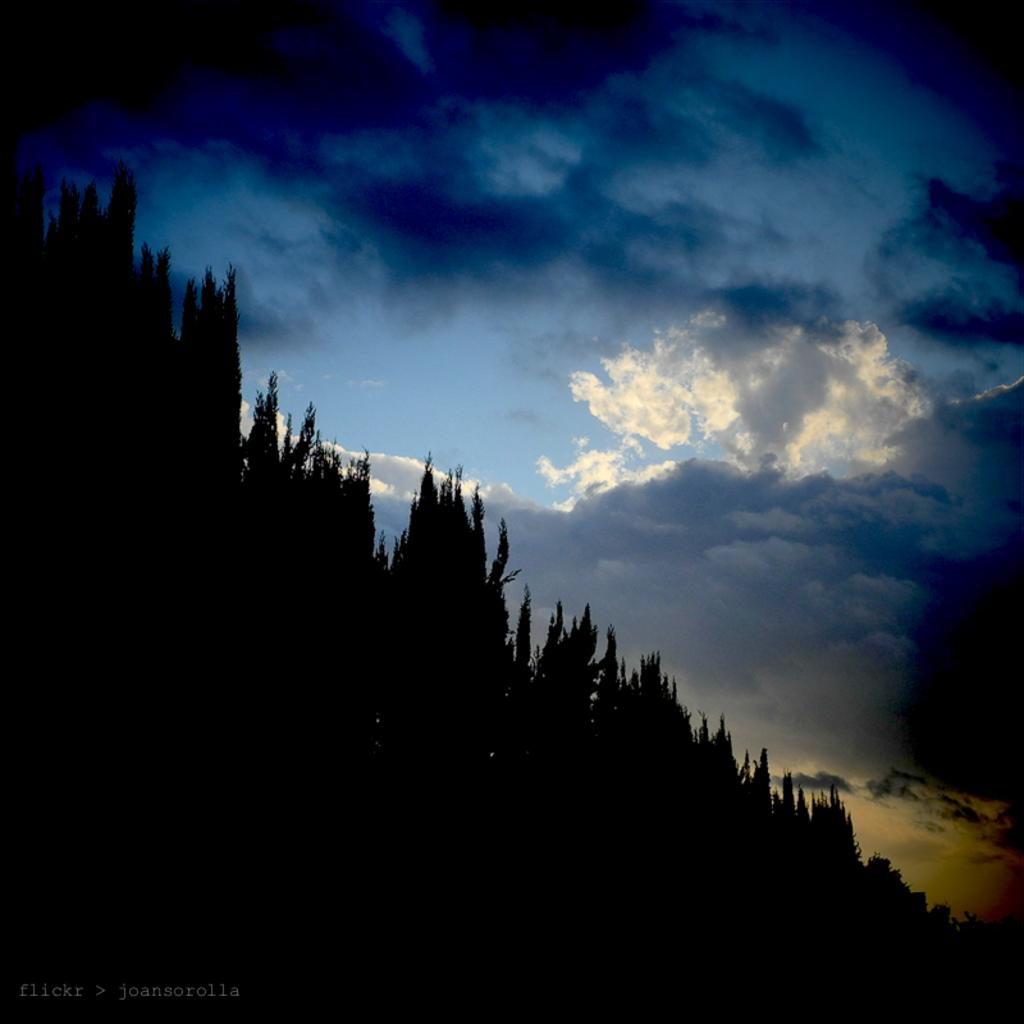What can be found on the bottom left of the image? There is a watermark on the bottom left of the image. What is visible in the background of the image? There are trees on a mountain in the background of the image. What can be seen in the sky in the image? There are clouds visible in the sky, and the sky is blue. What type of cat is sitting on the breakfast table in the image? There is no cat or breakfast table present in the image. 